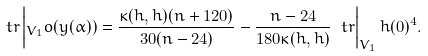<formula> <loc_0><loc_0><loc_500><loc_500>\ t r \left | _ { V _ { 1 } } o ( y ( \alpha ) ) = \frac { \kappa ( h , h ) ( n + 1 2 0 ) } { 3 0 ( n - 2 4 ) } - \frac { n - 2 4 } { 1 8 0 \kappa ( h , h ) } \ t r \right | _ { V _ { 1 } } h ( 0 ) ^ { 4 } .</formula> 